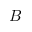Convert formula to latex. <formula><loc_0><loc_0><loc_500><loc_500>B</formula> 